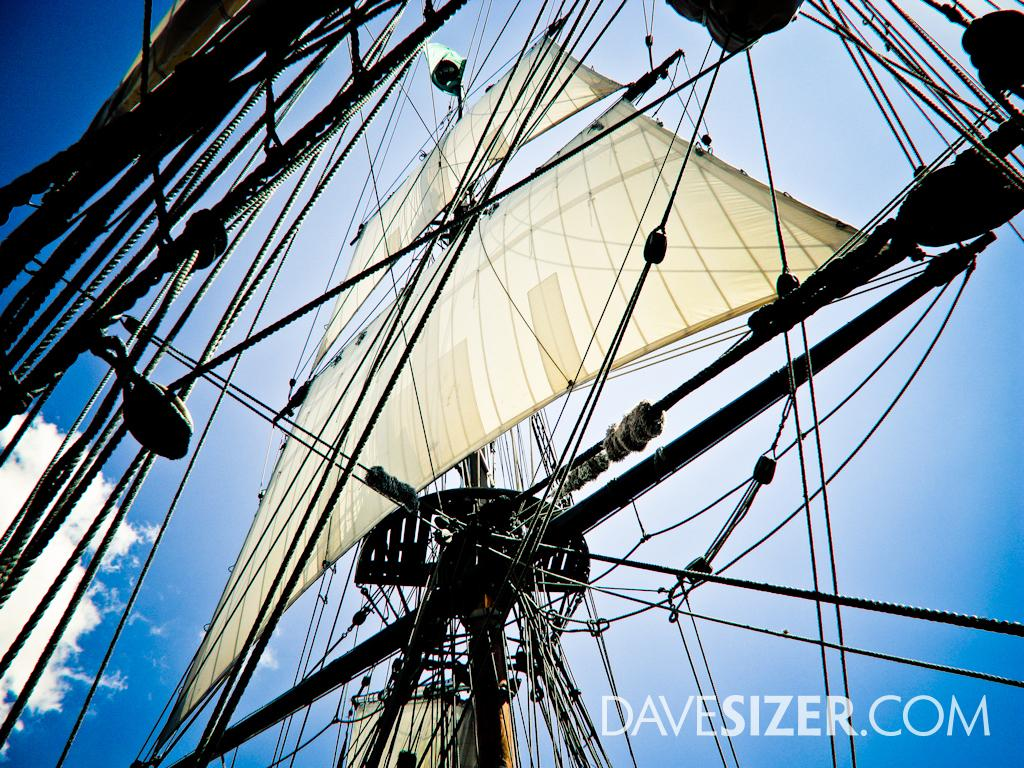What type of objects can be seen in abundance in the image? There are many poles and rods in the image. What is the color of the cloth visible in the image? There is a cream-colored cloth in the image. What can be seen in the sky in the image? There are clouds visible in the image. What color is the sky in the image? The sky is blue in the image. Can you see a snail climbing up the hill in the image? There is no hill or snail present in the image. 